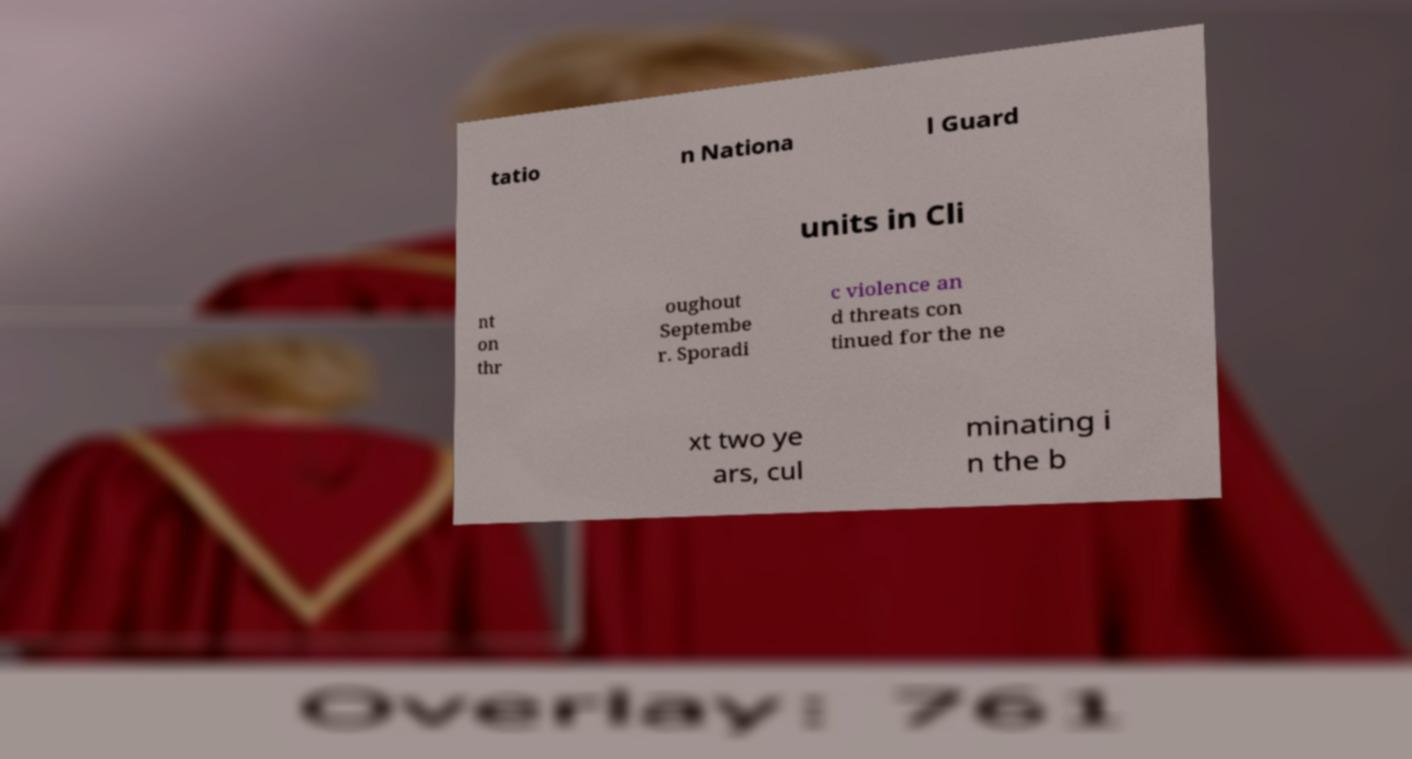Could you extract and type out the text from this image? tatio n Nationa l Guard units in Cli nt on thr oughout Septembe r. Sporadi c violence an d threats con tinued for the ne xt two ye ars, cul minating i n the b 